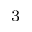<formula> <loc_0><loc_0><loc_500><loc_500>^ { 3 }</formula> 